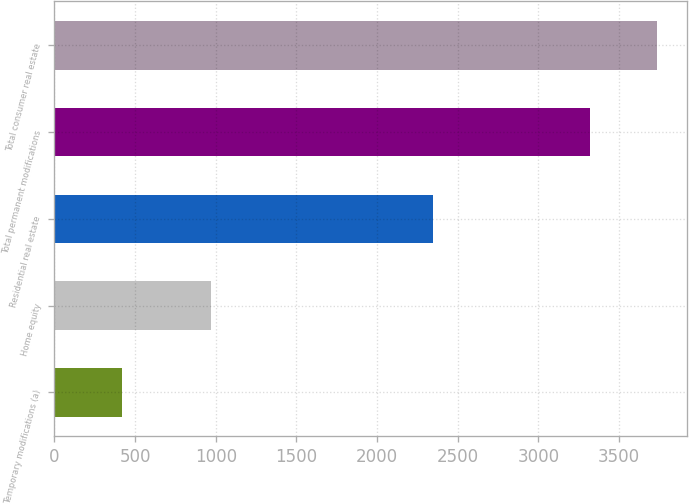Convert chart to OTSL. <chart><loc_0><loc_0><loc_500><loc_500><bar_chart><fcel>Temporary modifications (a)<fcel>Home equity<fcel>Residential real estate<fcel>Total permanent modifications<fcel>Total consumer real estate<nl><fcel>417<fcel>968<fcel>2350<fcel>3318<fcel>3735<nl></chart> 